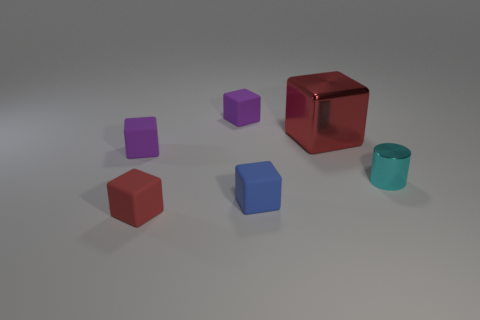Is the large red block made of the same material as the small red cube?
Offer a very short reply. No. What number of blocks are either large metallic objects or brown rubber things?
Provide a succinct answer. 1. What color is the matte block that is in front of the tiny blue rubber block?
Offer a very short reply. Red. How many rubber things are either blocks or large cyan cubes?
Make the answer very short. 4. What material is the thing that is left of the red block that is to the left of the large object?
Your response must be concise. Rubber. There is another object that is the same color as the big shiny thing; what is it made of?
Keep it short and to the point. Rubber. What is the color of the large shiny block?
Keep it short and to the point. Red. Is there a small cyan metallic thing that is in front of the metal object behind the small cyan cylinder?
Offer a very short reply. Yes. What is the small blue block made of?
Offer a very short reply. Rubber. Are the purple cube to the right of the tiny red rubber object and the red block to the left of the blue cube made of the same material?
Your answer should be very brief. Yes. 